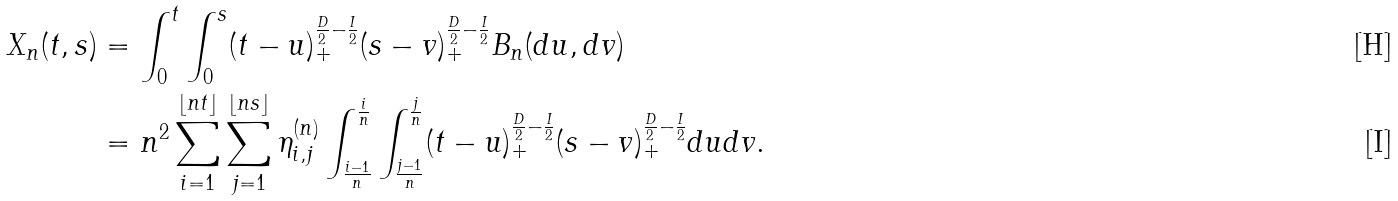Convert formula to latex. <formula><loc_0><loc_0><loc_500><loc_500>X _ { n } ( t , s ) & = \int _ { 0 } ^ { t } \int _ { 0 } ^ { s } ( t - u ) _ { + } ^ { \frac { D } { 2 } - \frac { I } { 2 } } ( s - v ) _ { + } ^ { \frac { D } { 2 } - \frac { I } { 2 } } B _ { n } ( d u , d v ) \\ & = n ^ { 2 } \sum _ { i = 1 } ^ { \lfloor n t \rfloor } \sum _ { j = 1 } ^ { \lfloor n s \rfloor } \eta _ { i , j } ^ { ( n ) } \int _ { \frac { i - 1 } { n } } ^ { \frac { i } { n } } \int _ { \frac { j - 1 } { n } } ^ { \frac { j } { n } } ( t - u ) _ { + } ^ { \frac { D } { 2 } - \frac { I } { 2 } } ( s - v ) _ { + } ^ { \frac { D } { 2 } - \frac { I } { 2 } } d u d v .</formula> 